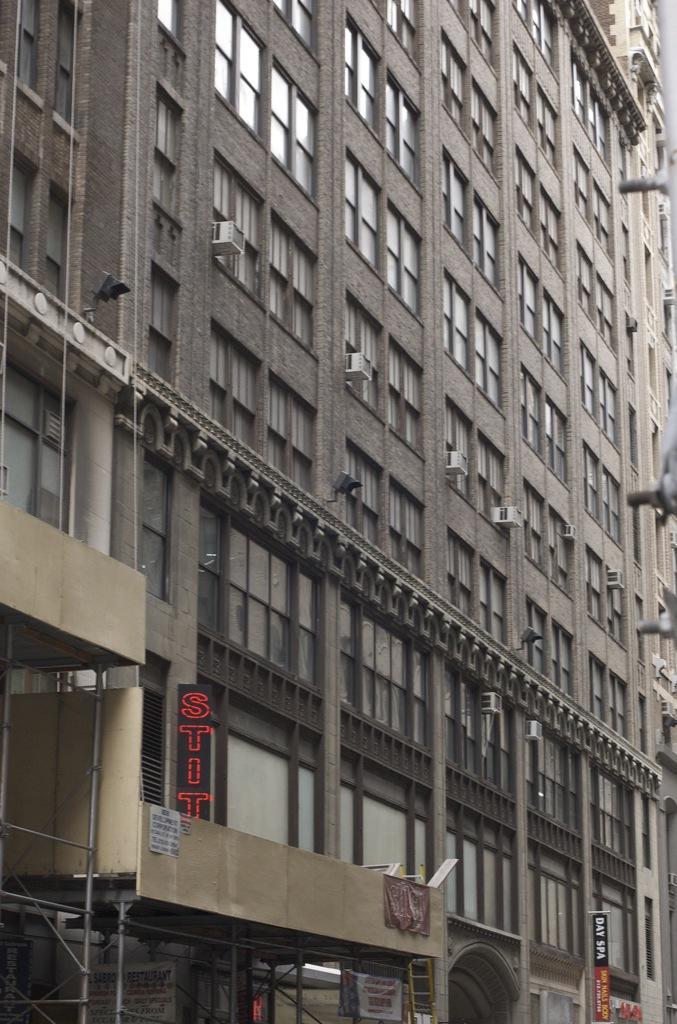Describe this image in one or two sentences. In this image, I can see a building with glass windows, outdoor window AC units and lights. At the bottom of the image, I can see the name boards, iron rods and few other things. 